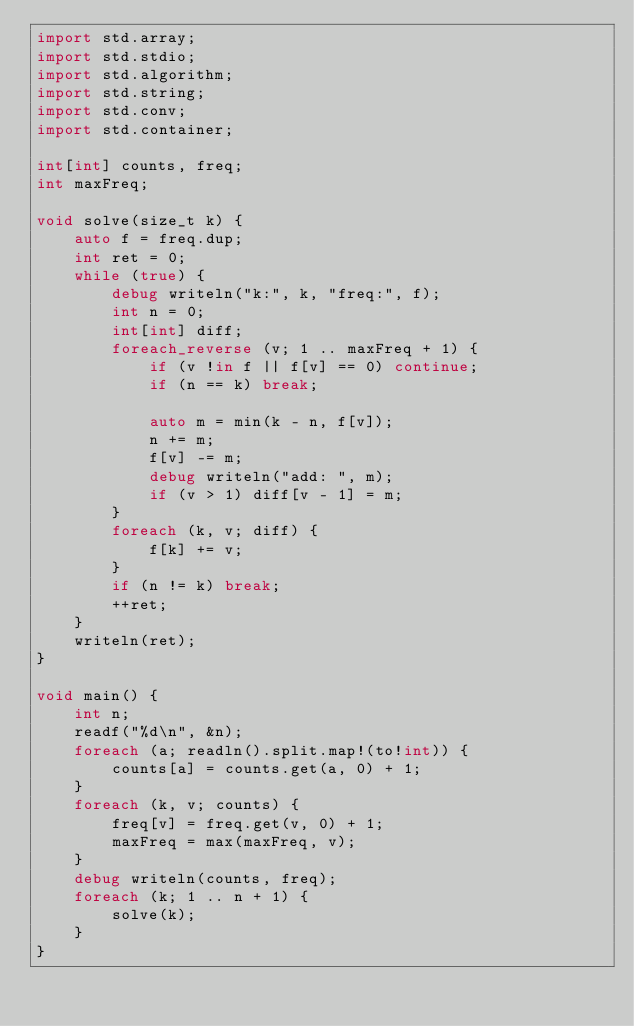Convert code to text. <code><loc_0><loc_0><loc_500><loc_500><_D_>import std.array;
import std.stdio;
import std.algorithm;
import std.string;
import std.conv;
import std.container;

int[int] counts, freq;
int maxFreq;

void solve(size_t k) {
    auto f = freq.dup;
    int ret = 0;
    while (true) {
        debug writeln("k:", k, "freq:", f);
        int n = 0;
        int[int] diff;
        foreach_reverse (v; 1 .. maxFreq + 1) {
            if (v !in f || f[v] == 0) continue;
            if (n == k) break;

            auto m = min(k - n, f[v]);
            n += m;
            f[v] -= m;
            debug writeln("add: ", m);
            if (v > 1) diff[v - 1] = m;
        }
        foreach (k, v; diff) {
            f[k] += v;
        }
        if (n != k) break;
        ++ret;
    }
    writeln(ret);
}

void main() {
    int n;
    readf("%d\n", &n);
    foreach (a; readln().split.map!(to!int)) {
        counts[a] = counts.get(a, 0) + 1;
    }
    foreach (k, v; counts) {
        freq[v] = freq.get(v, 0) + 1;
        maxFreq = max(maxFreq, v);
    }
    debug writeln(counts, freq);
    foreach (k; 1 .. n + 1) {
        solve(k);
    }
}
</code> 